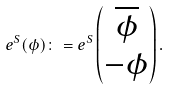Convert formula to latex. <formula><loc_0><loc_0><loc_500><loc_500>e ^ { S } ( \phi ) \colon = e ^ { S } \left ( \begin{matrix} \overline { \phi } \\ - \phi \end{matrix} \right ) .</formula> 